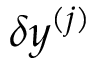<formula> <loc_0><loc_0><loc_500><loc_500>\delta y ^ { ( j ) }</formula> 